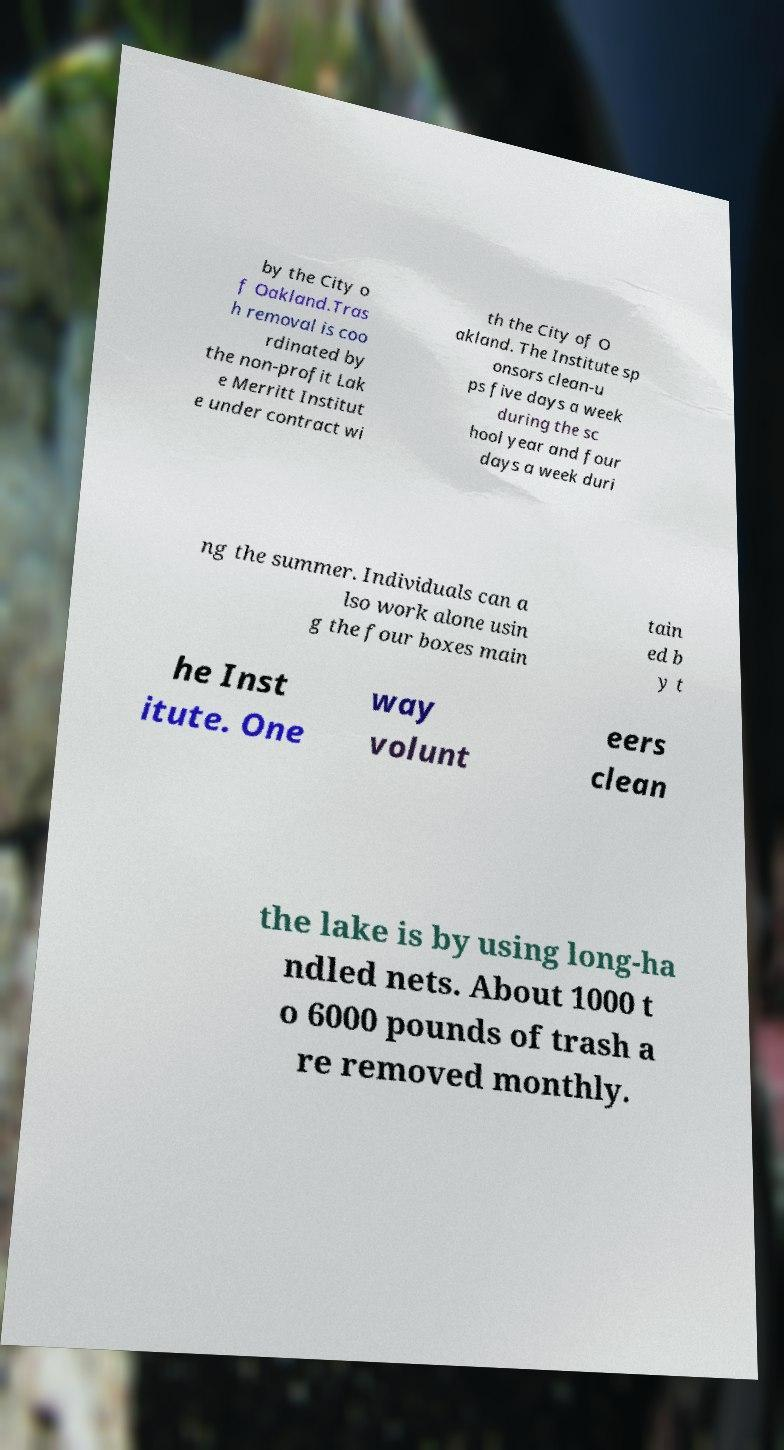Please read and relay the text visible in this image. What does it say? by the City o f Oakland.Tras h removal is coo rdinated by the non-profit Lak e Merritt Institut e under contract wi th the City of O akland. The Institute sp onsors clean-u ps five days a week during the sc hool year and four days a week duri ng the summer. Individuals can a lso work alone usin g the four boxes main tain ed b y t he Inst itute. One way volunt eers clean the lake is by using long-ha ndled nets. About 1000 t o 6000 pounds of trash a re removed monthly. 